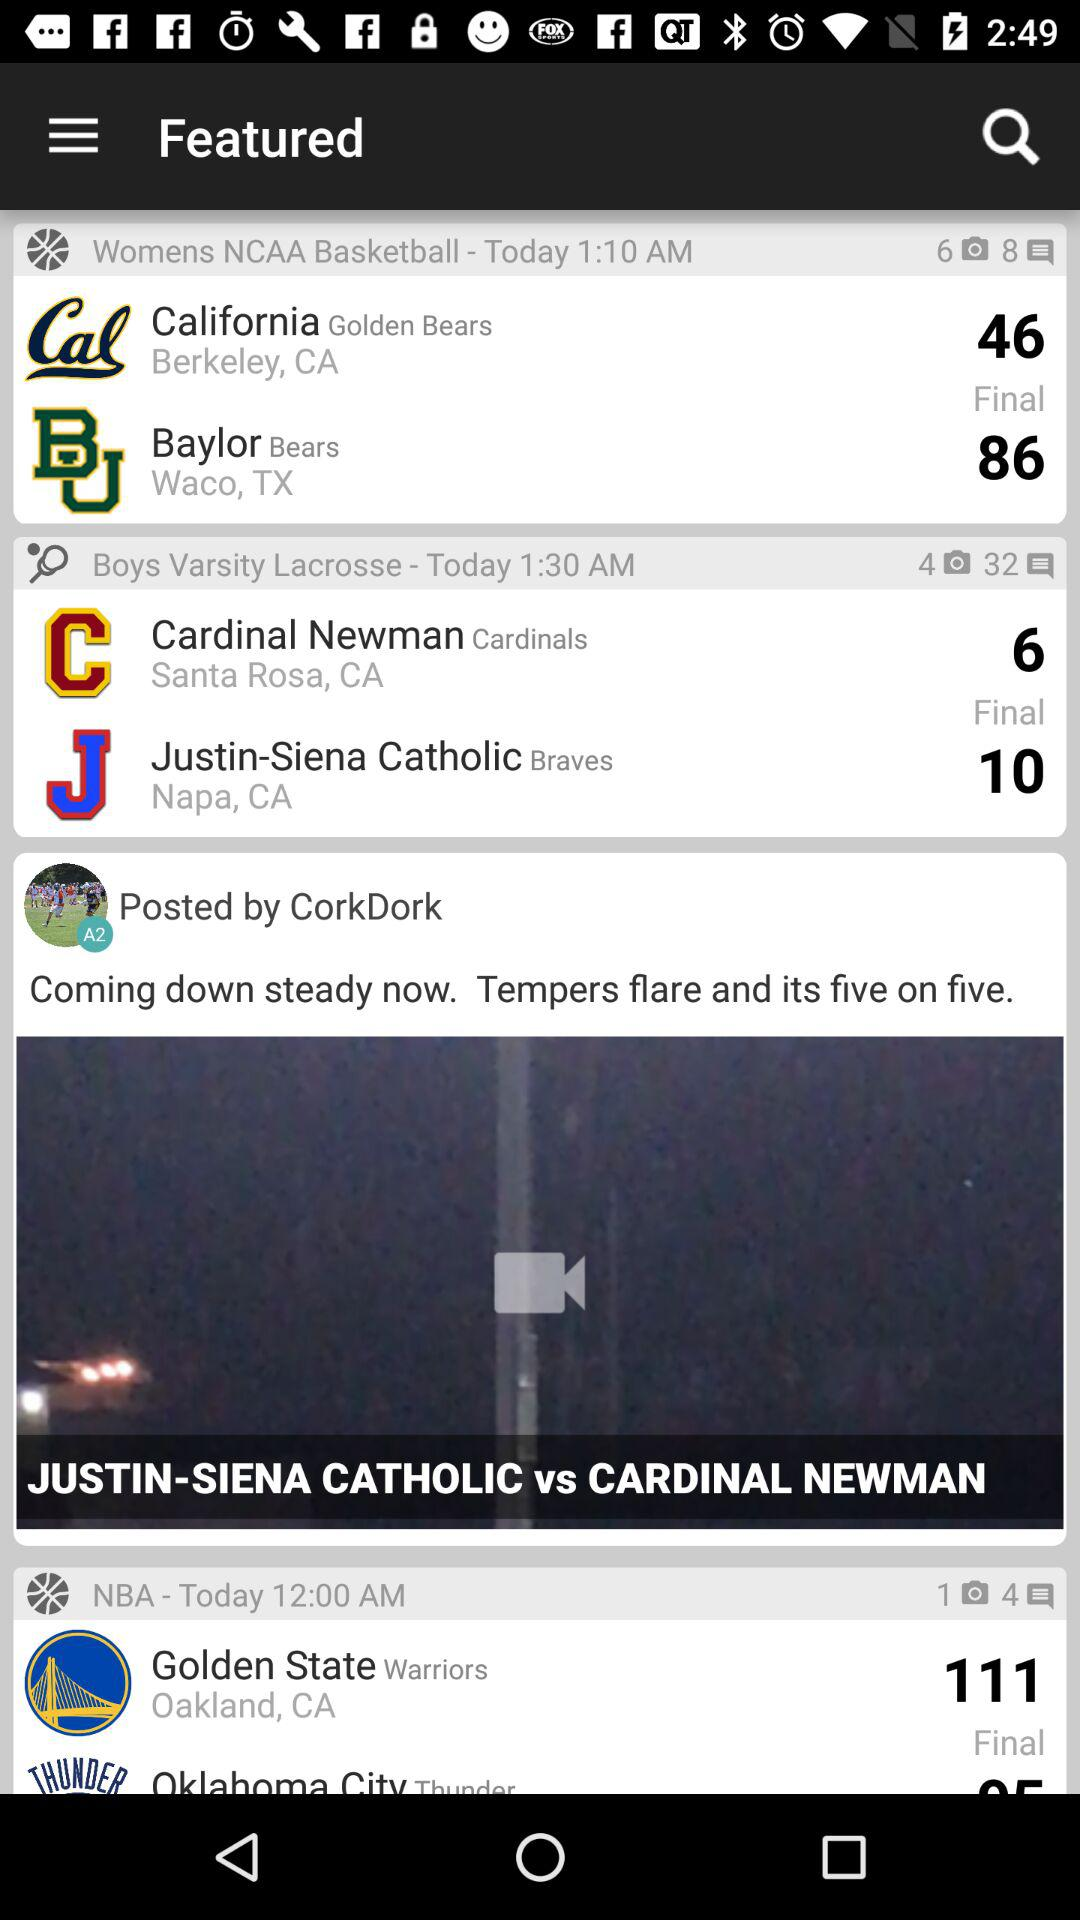When did "CorkDork" make their post?
When the provided information is insufficient, respond with <no answer>. <no answer> 